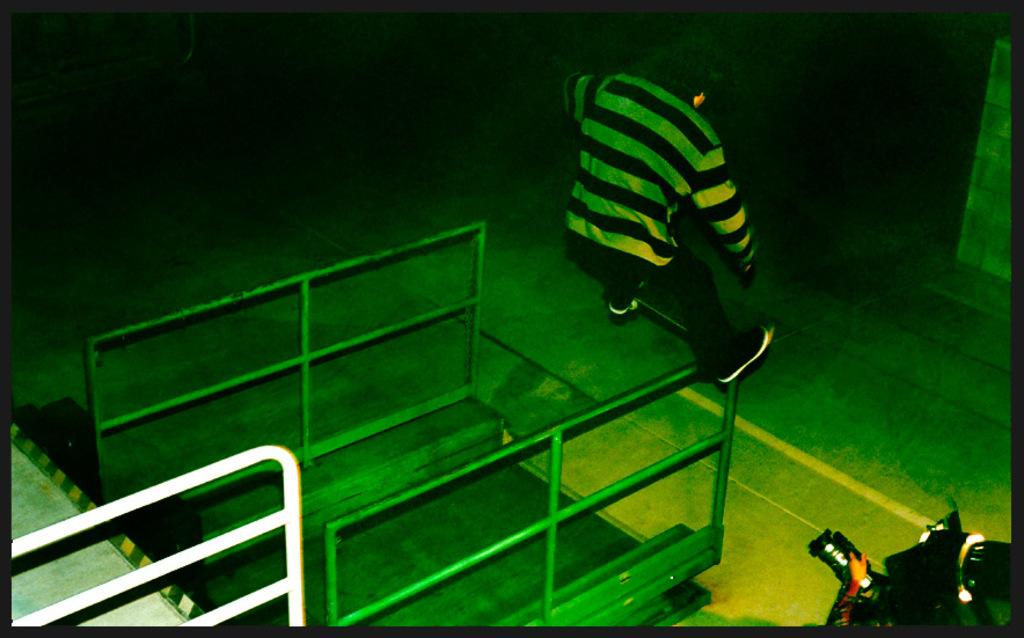What can be seen at the bottom of the image? There is a trolley at the bottom of the image. What is located on the left side of the image? There is a railing on the left side of the image. Who or what is in the center of the image? There is a man in the center of the image. What is present on the right side of the image? There is an object on the right side of the image. What can be seen in the background of the image? There is a wall in the background of the image. How many snails are crawling on the railing in the image? There are no snails present in the image. What time of day is depicted in the image? The time of day cannot be determined from the image. 